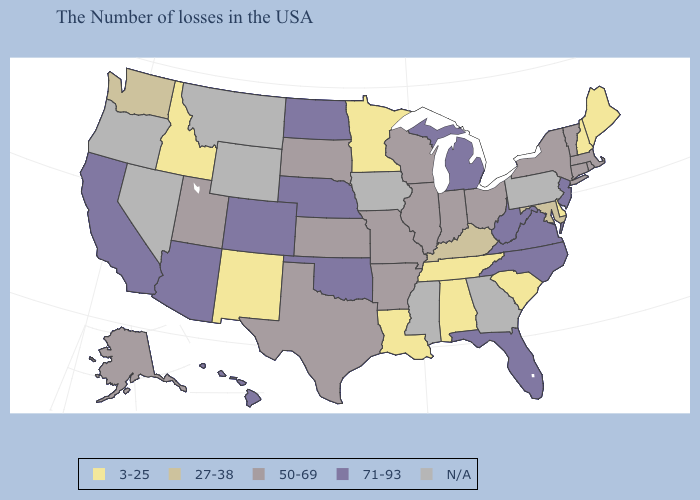What is the lowest value in the MidWest?
Keep it brief. 3-25. Name the states that have a value in the range N/A?
Concise answer only. Pennsylvania, Georgia, Mississippi, Iowa, Wyoming, Montana, Nevada, Oregon. What is the lowest value in the USA?
Give a very brief answer. 3-25. Name the states that have a value in the range 50-69?
Answer briefly. Massachusetts, Rhode Island, Vermont, Connecticut, New York, Ohio, Indiana, Wisconsin, Illinois, Missouri, Arkansas, Kansas, Texas, South Dakota, Utah, Alaska. Among the states that border New Jersey , does New York have the highest value?
Be succinct. Yes. Does the first symbol in the legend represent the smallest category?
Concise answer only. Yes. What is the value of West Virginia?
Short answer required. 71-93. Among the states that border Vermont , which have the lowest value?
Concise answer only. New Hampshire. Which states hav the highest value in the MidWest?
Be succinct. Michigan, Nebraska, North Dakota. What is the lowest value in the USA?
Answer briefly. 3-25. Which states have the lowest value in the USA?
Concise answer only. Maine, New Hampshire, Delaware, South Carolina, Alabama, Tennessee, Louisiana, Minnesota, New Mexico, Idaho. What is the value of Virginia?
Write a very short answer. 71-93. Does West Virginia have the lowest value in the South?
Write a very short answer. No. What is the value of Virginia?
Write a very short answer. 71-93. 